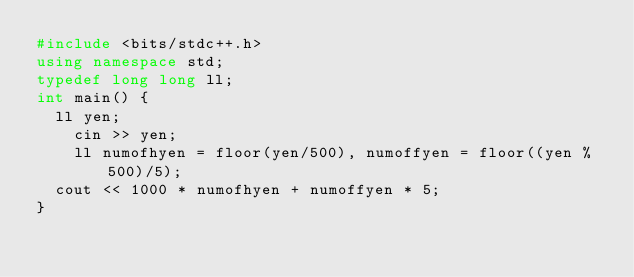Convert code to text. <code><loc_0><loc_0><loc_500><loc_500><_C++_>#include <bits/stdc++.h>
using namespace std;
typedef long long ll;
int main() {
	ll yen;
  	cin >> yen;
  	ll numofhyen = floor(yen/500), numoffyen = floor((yen % 500)/5);
  cout << 1000 * numofhyen + numoffyen * 5; 
}
  </code> 